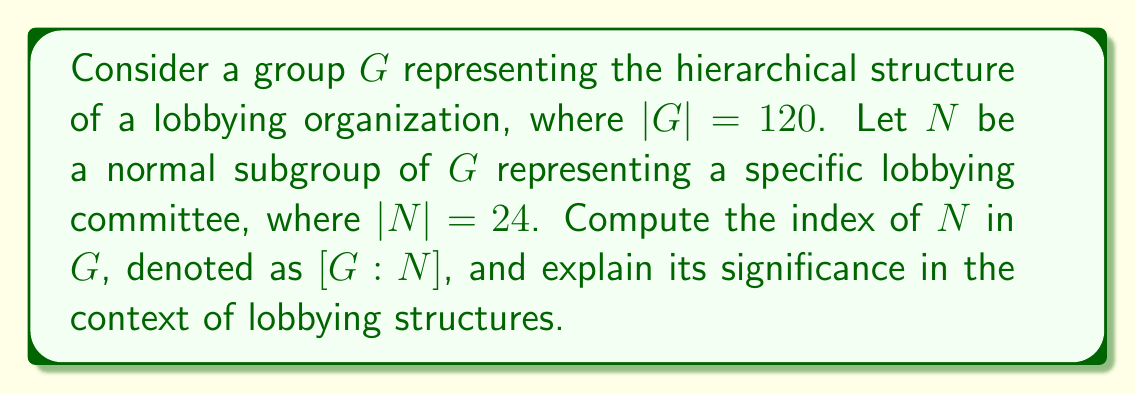Help me with this question. To solve this problem, we need to understand the concept of index in group theory and its application to hierarchical lobbying structures:

1. The index of a subgroup $N$ in a group $G$, denoted as $[G:N]$, is defined as the number of distinct left (or right) cosets of $N$ in $G$. It can be calculated using the formula:

   $$[G:N] = \frac{|G|}{|N|}$$

   where $|G|$ is the order of the group $G$, and $|N|$ is the order of the subgroup $N$.

2. In this case, we have:
   $|G| = 120$ (order of the entire lobbying organization)
   $|N| = 24$ (order of the specific lobbying committee)

3. Applying the formula:

   $$[G:N] = \frac{|G|}{|N|} = \frac{120}{24} = 5$$

4. Interpretation in the context of lobbying structures:
   - The index $[G:N] = 5$ indicates that there are 5 distinct cosets of $N$ in $G$.
   - In the lobbying context, this can be interpreted as 5 different levels or divisions within the organization's hierarchy.
   - Each coset represents a distinct set of lobbying activities or responsibilities that are equivalent under the structure defined by the subgroup $N$.
   - This hierarchical structure helps in organizing and delegating lobbying efforts efficiently within the organization.

5. Significance for ethics and lobbying regulations:
   - Understanding the index and structure of lobbying organizations can help in creating more effective and targeted regulations.
   - It provides insight into how information and decisions may flow through the organization's hierarchy.
   - Regulators can use this information to ensure proper oversight and accountability at each level of the lobbying structure.
Answer: The index of $N$ in $G$ is $[G:N] = 5$, representing 5 distinct levels or divisions in the lobbying organization's hierarchical structure. 